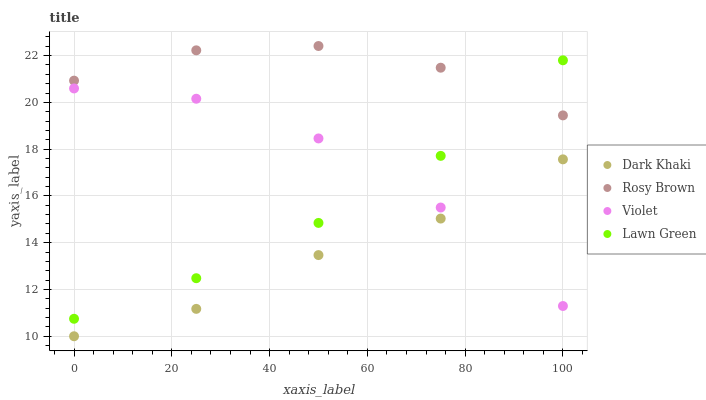Does Dark Khaki have the minimum area under the curve?
Answer yes or no. Yes. Does Rosy Brown have the maximum area under the curve?
Answer yes or no. Yes. Does Lawn Green have the minimum area under the curve?
Answer yes or no. No. Does Lawn Green have the maximum area under the curve?
Answer yes or no. No. Is Lawn Green the smoothest?
Answer yes or no. Yes. Is Violet the roughest?
Answer yes or no. Yes. Is Rosy Brown the smoothest?
Answer yes or no. No. Is Rosy Brown the roughest?
Answer yes or no. No. Does Dark Khaki have the lowest value?
Answer yes or no. Yes. Does Lawn Green have the lowest value?
Answer yes or no. No. Does Rosy Brown have the highest value?
Answer yes or no. Yes. Does Lawn Green have the highest value?
Answer yes or no. No. Is Dark Khaki less than Rosy Brown?
Answer yes or no. Yes. Is Rosy Brown greater than Dark Khaki?
Answer yes or no. Yes. Does Lawn Green intersect Violet?
Answer yes or no. Yes. Is Lawn Green less than Violet?
Answer yes or no. No. Is Lawn Green greater than Violet?
Answer yes or no. No. Does Dark Khaki intersect Rosy Brown?
Answer yes or no. No. 